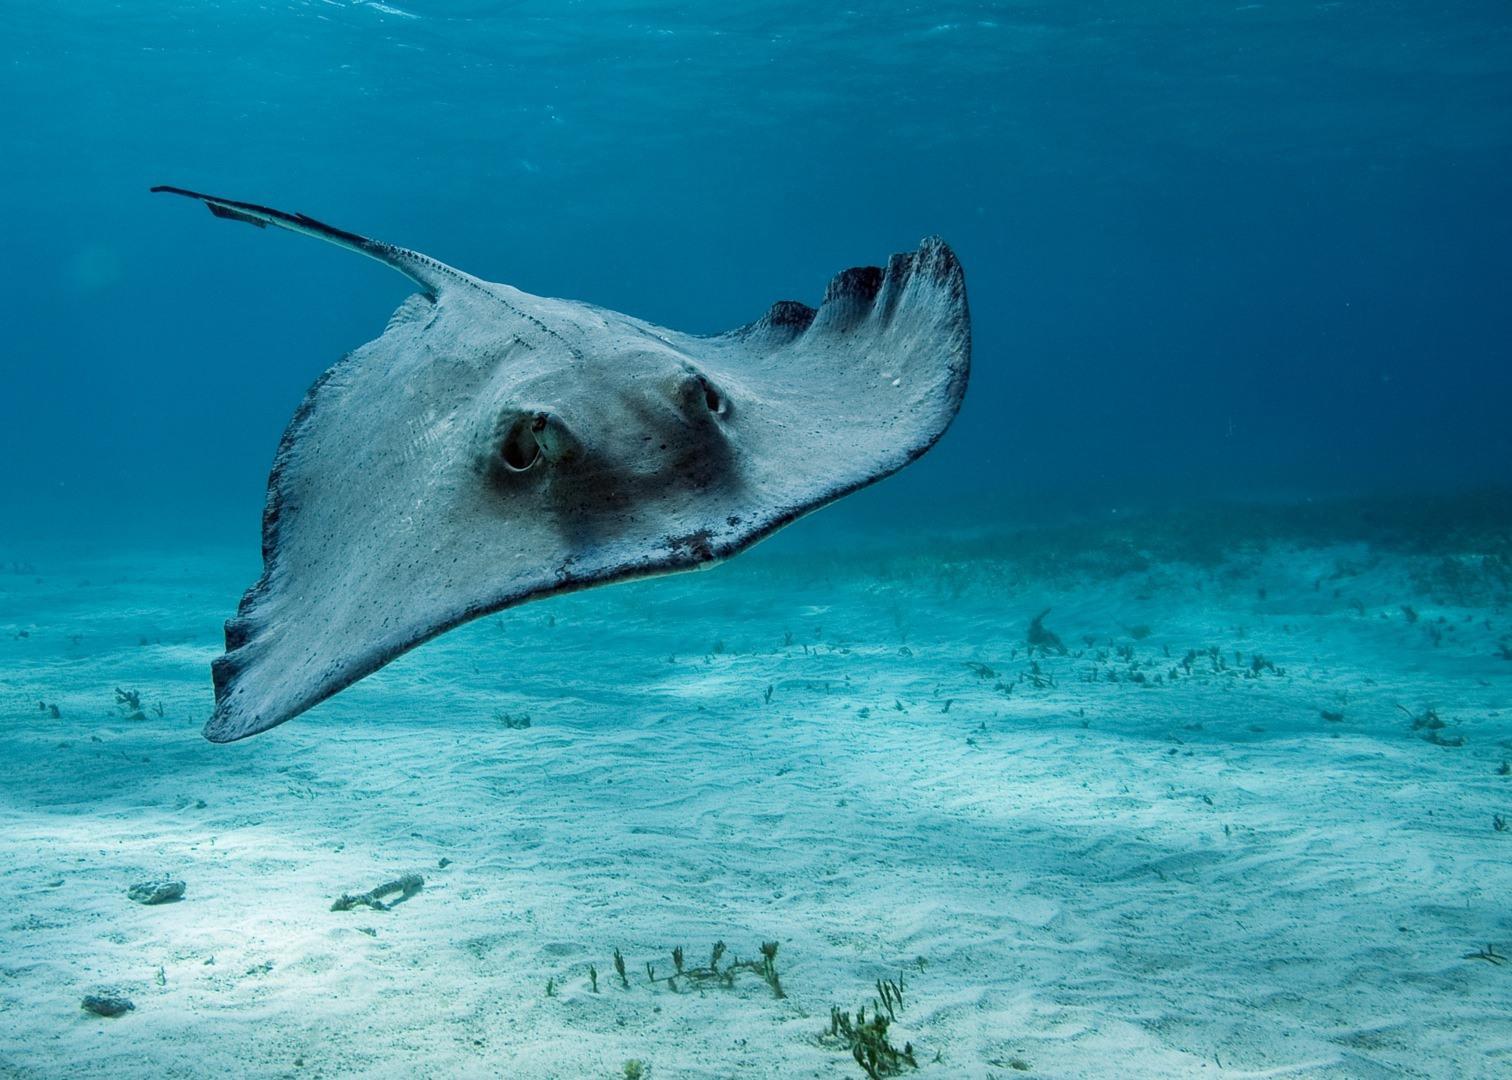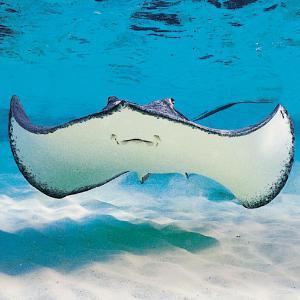The first image is the image on the left, the second image is the image on the right. Examine the images to the left and right. Is the description "There is at least one person in the water with at least one manta ray." accurate? Answer yes or no. No. The first image is the image on the left, the second image is the image on the right. Assess this claim about the two images: "Two or more people are in very clear ocean water with manta rays swimming around them.". Correct or not? Answer yes or no. No. 